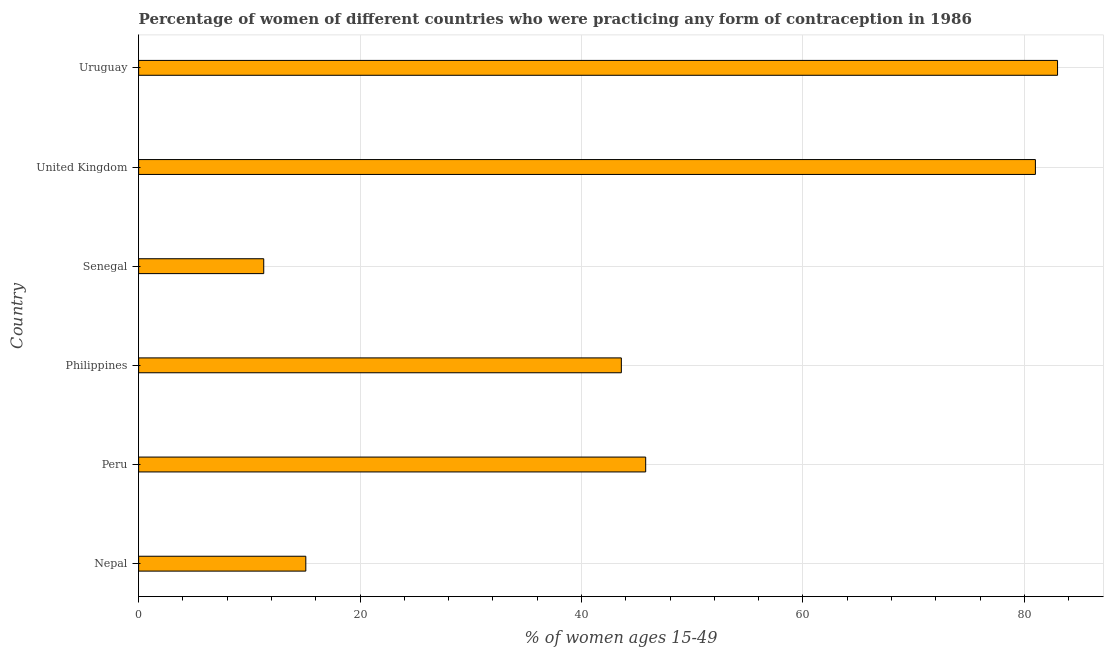Does the graph contain grids?
Keep it short and to the point. Yes. What is the title of the graph?
Provide a short and direct response. Percentage of women of different countries who were practicing any form of contraception in 1986. What is the label or title of the X-axis?
Provide a succinct answer. % of women ages 15-49. What is the label or title of the Y-axis?
Offer a terse response. Country. What is the contraceptive prevalence in Philippines?
Provide a short and direct response. 43.6. Across all countries, what is the maximum contraceptive prevalence?
Ensure brevity in your answer.  83. Across all countries, what is the minimum contraceptive prevalence?
Provide a succinct answer. 11.3. In which country was the contraceptive prevalence maximum?
Offer a terse response. Uruguay. In which country was the contraceptive prevalence minimum?
Provide a short and direct response. Senegal. What is the sum of the contraceptive prevalence?
Provide a succinct answer. 279.8. What is the difference between the contraceptive prevalence in Philippines and Senegal?
Make the answer very short. 32.3. What is the average contraceptive prevalence per country?
Offer a terse response. 46.63. What is the median contraceptive prevalence?
Give a very brief answer. 44.7. What is the ratio of the contraceptive prevalence in Nepal to that in United Kingdom?
Make the answer very short. 0.19. Is the contraceptive prevalence in Senegal less than that in United Kingdom?
Your response must be concise. Yes. Is the difference between the contraceptive prevalence in Peru and Philippines greater than the difference between any two countries?
Provide a short and direct response. No. What is the difference between the highest and the lowest contraceptive prevalence?
Your answer should be compact. 71.7. In how many countries, is the contraceptive prevalence greater than the average contraceptive prevalence taken over all countries?
Your response must be concise. 2. How many bars are there?
Provide a short and direct response. 6. What is the difference between two consecutive major ticks on the X-axis?
Provide a succinct answer. 20. What is the % of women ages 15-49 of Peru?
Keep it short and to the point. 45.8. What is the % of women ages 15-49 in Philippines?
Provide a short and direct response. 43.6. What is the % of women ages 15-49 in Senegal?
Ensure brevity in your answer.  11.3. What is the % of women ages 15-49 in United Kingdom?
Your answer should be very brief. 81. What is the difference between the % of women ages 15-49 in Nepal and Peru?
Offer a terse response. -30.7. What is the difference between the % of women ages 15-49 in Nepal and Philippines?
Your answer should be compact. -28.5. What is the difference between the % of women ages 15-49 in Nepal and Senegal?
Your response must be concise. 3.8. What is the difference between the % of women ages 15-49 in Nepal and United Kingdom?
Offer a terse response. -65.9. What is the difference between the % of women ages 15-49 in Nepal and Uruguay?
Offer a terse response. -67.9. What is the difference between the % of women ages 15-49 in Peru and Philippines?
Your response must be concise. 2.2. What is the difference between the % of women ages 15-49 in Peru and Senegal?
Give a very brief answer. 34.5. What is the difference between the % of women ages 15-49 in Peru and United Kingdom?
Provide a succinct answer. -35.2. What is the difference between the % of women ages 15-49 in Peru and Uruguay?
Make the answer very short. -37.2. What is the difference between the % of women ages 15-49 in Philippines and Senegal?
Your answer should be very brief. 32.3. What is the difference between the % of women ages 15-49 in Philippines and United Kingdom?
Provide a succinct answer. -37.4. What is the difference between the % of women ages 15-49 in Philippines and Uruguay?
Provide a short and direct response. -39.4. What is the difference between the % of women ages 15-49 in Senegal and United Kingdom?
Your answer should be very brief. -69.7. What is the difference between the % of women ages 15-49 in Senegal and Uruguay?
Your answer should be very brief. -71.7. What is the difference between the % of women ages 15-49 in United Kingdom and Uruguay?
Make the answer very short. -2. What is the ratio of the % of women ages 15-49 in Nepal to that in Peru?
Your answer should be compact. 0.33. What is the ratio of the % of women ages 15-49 in Nepal to that in Philippines?
Your answer should be very brief. 0.35. What is the ratio of the % of women ages 15-49 in Nepal to that in Senegal?
Make the answer very short. 1.34. What is the ratio of the % of women ages 15-49 in Nepal to that in United Kingdom?
Keep it short and to the point. 0.19. What is the ratio of the % of women ages 15-49 in Nepal to that in Uruguay?
Your response must be concise. 0.18. What is the ratio of the % of women ages 15-49 in Peru to that in Philippines?
Give a very brief answer. 1.05. What is the ratio of the % of women ages 15-49 in Peru to that in Senegal?
Offer a terse response. 4.05. What is the ratio of the % of women ages 15-49 in Peru to that in United Kingdom?
Ensure brevity in your answer.  0.56. What is the ratio of the % of women ages 15-49 in Peru to that in Uruguay?
Your answer should be very brief. 0.55. What is the ratio of the % of women ages 15-49 in Philippines to that in Senegal?
Keep it short and to the point. 3.86. What is the ratio of the % of women ages 15-49 in Philippines to that in United Kingdom?
Make the answer very short. 0.54. What is the ratio of the % of women ages 15-49 in Philippines to that in Uruguay?
Provide a succinct answer. 0.53. What is the ratio of the % of women ages 15-49 in Senegal to that in United Kingdom?
Offer a terse response. 0.14. What is the ratio of the % of women ages 15-49 in Senegal to that in Uruguay?
Make the answer very short. 0.14. What is the ratio of the % of women ages 15-49 in United Kingdom to that in Uruguay?
Give a very brief answer. 0.98. 